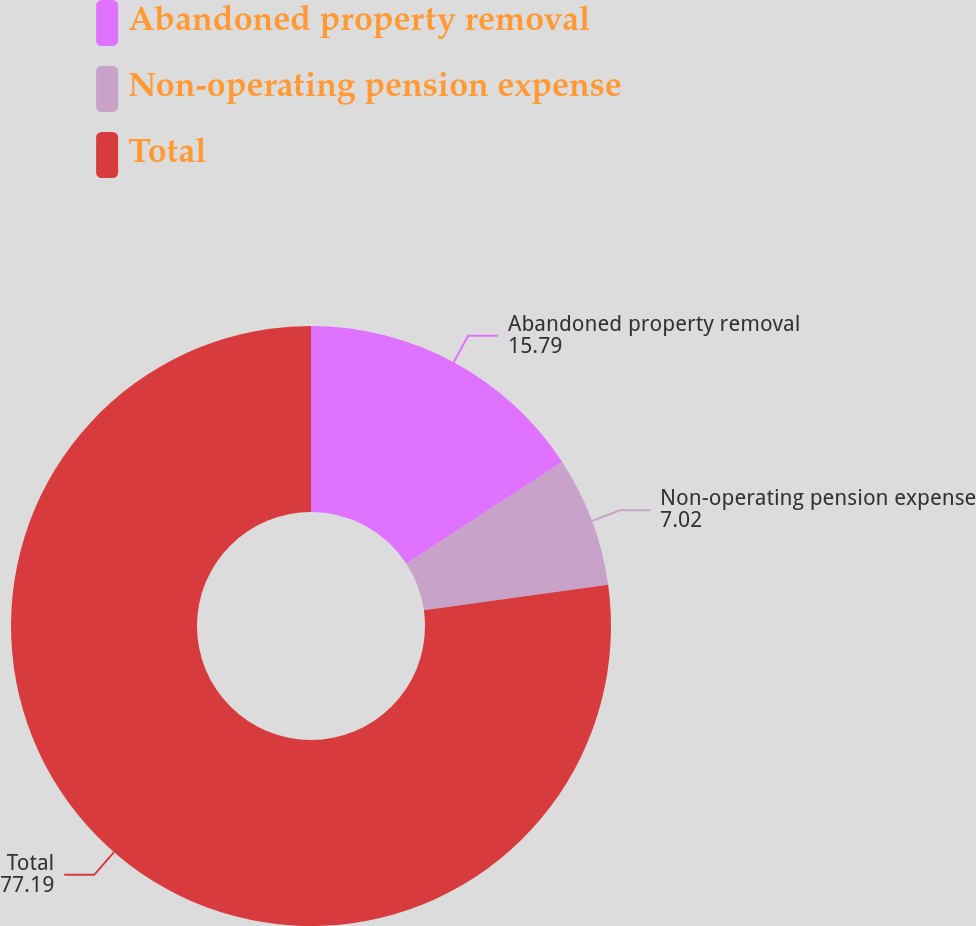<chart> <loc_0><loc_0><loc_500><loc_500><pie_chart><fcel>Abandoned property removal<fcel>Non-operating pension expense<fcel>Total<nl><fcel>15.79%<fcel>7.02%<fcel>77.19%<nl></chart> 